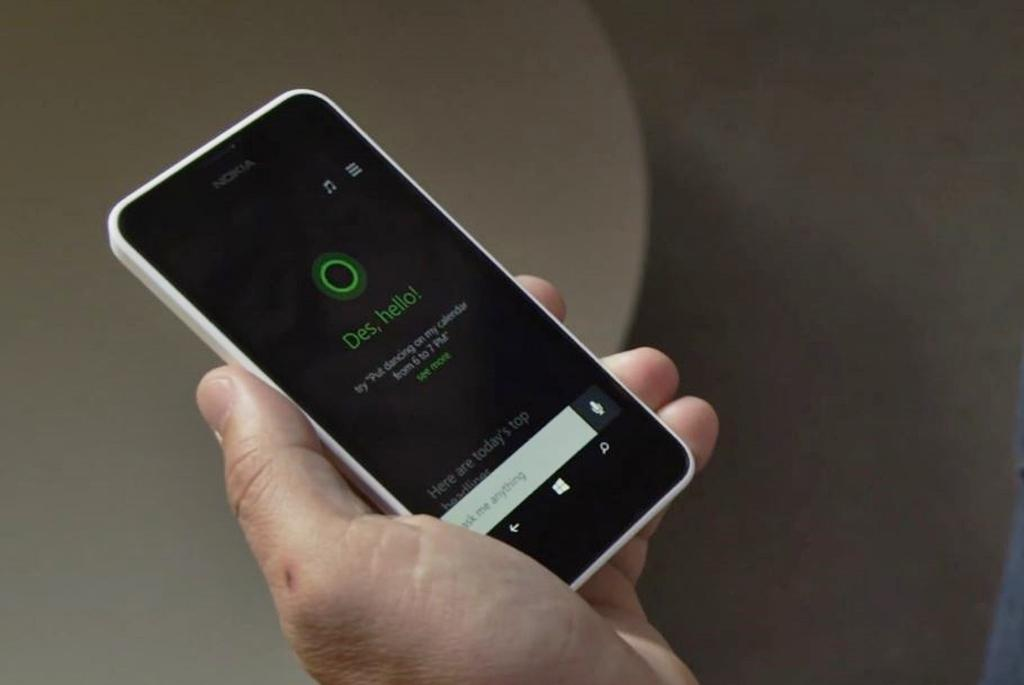<image>
Give a short and clear explanation of the subsequent image. A phone with cortana on it that says Des, hello 